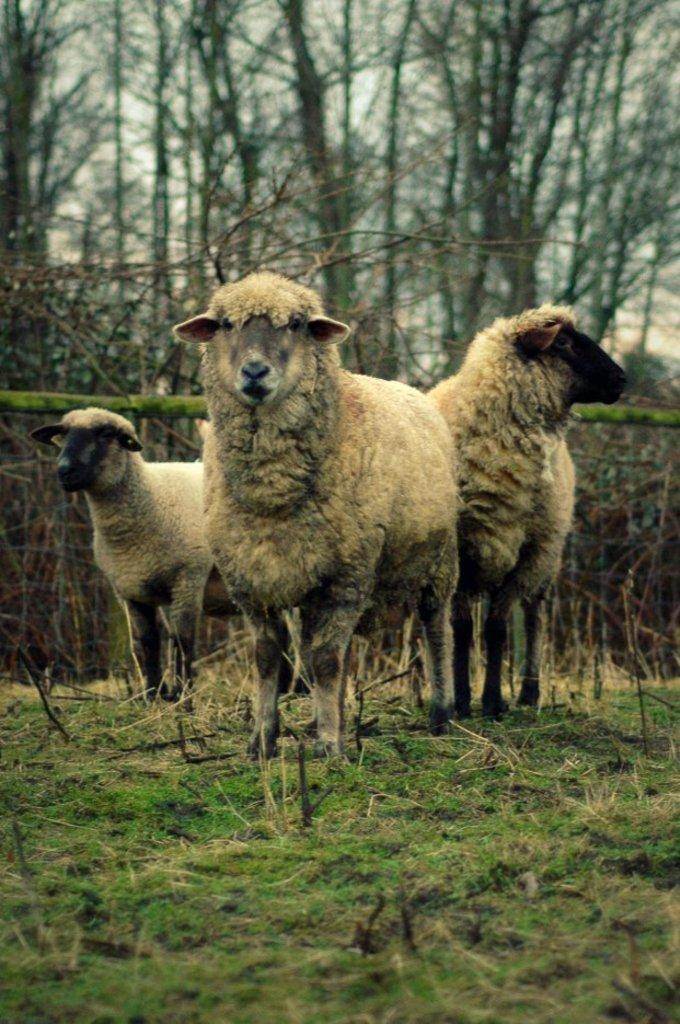How many sheep are present in the image? There are three sheep in the image. What is the setting in which the sheep are located? The sheep are in a green field. What can be seen in the background of the image? There are trees visible in the background of the image. What number is the sheep giving its approval for in the image? There is no indication in the image that the sheep are giving any form of approval or expressing a preference for a specific number. 